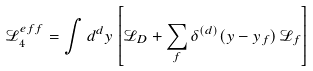Convert formula to latex. <formula><loc_0><loc_0><loc_500><loc_500>\mathcal { L } _ { 4 } ^ { e f f } = \int d ^ { d } y \left [ \mathcal { L } _ { D } + \sum _ { f } \delta ^ { ( d ) } ( y - y _ { f } ) \, \mathcal { L } _ { f } \right ]</formula> 